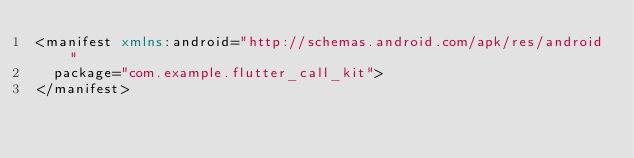<code> <loc_0><loc_0><loc_500><loc_500><_XML_><manifest xmlns:android="http://schemas.android.com/apk/res/android"
  package="com.example.flutter_call_kit">
</manifest>
</code> 